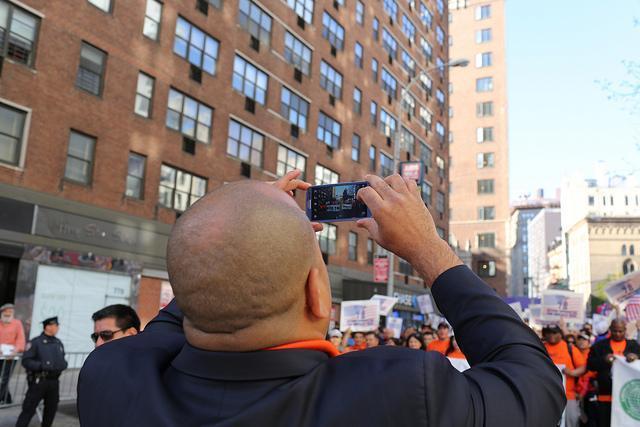How many people can be seen?
Give a very brief answer. 5. How many grey cars are there in the image?
Give a very brief answer. 0. 